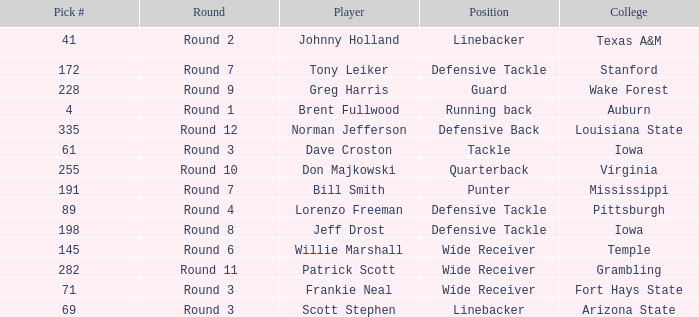Which college had Tony Leiker in round 7? Stanford. 